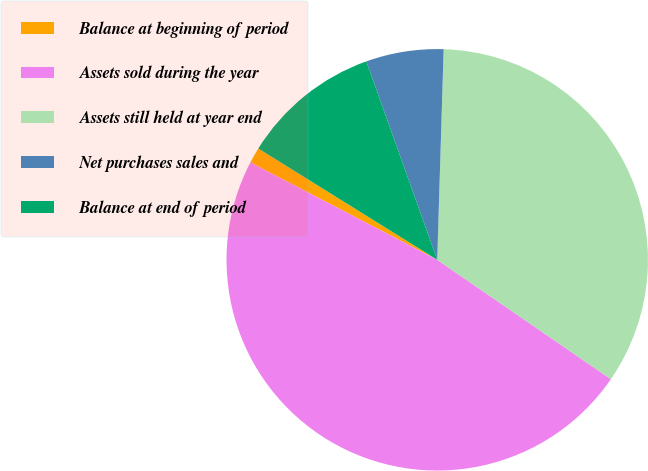Convert chart. <chart><loc_0><loc_0><loc_500><loc_500><pie_chart><fcel>Balance at beginning of period<fcel>Assets sold during the year<fcel>Assets still held at year end<fcel>Net purchases sales and<fcel>Balance at end of period<nl><fcel>1.21%<fcel>48.06%<fcel>34.1%<fcel>5.95%<fcel>10.68%<nl></chart> 